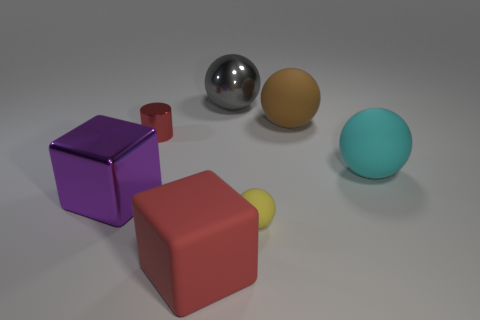Subtract all shiny balls. How many balls are left? 3 Add 1 large red metal things. How many objects exist? 8 Subtract all yellow spheres. How many spheres are left? 3 Subtract all spheres. How many objects are left? 3 Subtract all yellow balls. Subtract all red blocks. How many balls are left? 3 Subtract all red spheres. How many red cubes are left? 1 Subtract all tiny metal cylinders. Subtract all purple blocks. How many objects are left? 5 Add 7 matte spheres. How many matte spheres are left? 10 Add 6 tiny brown matte cylinders. How many tiny brown matte cylinders exist? 6 Subtract 0 green cylinders. How many objects are left? 7 